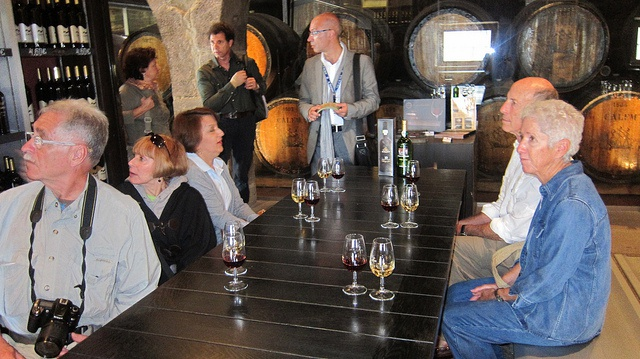Describe the objects in this image and their specific colors. I can see dining table in gray, black, and maroon tones, people in gray, darkgray, lightpink, and black tones, people in gray, tan, and darkgray tones, people in gray, darkgray, black, and lightgray tones, and people in gray, lightgray, and tan tones in this image. 